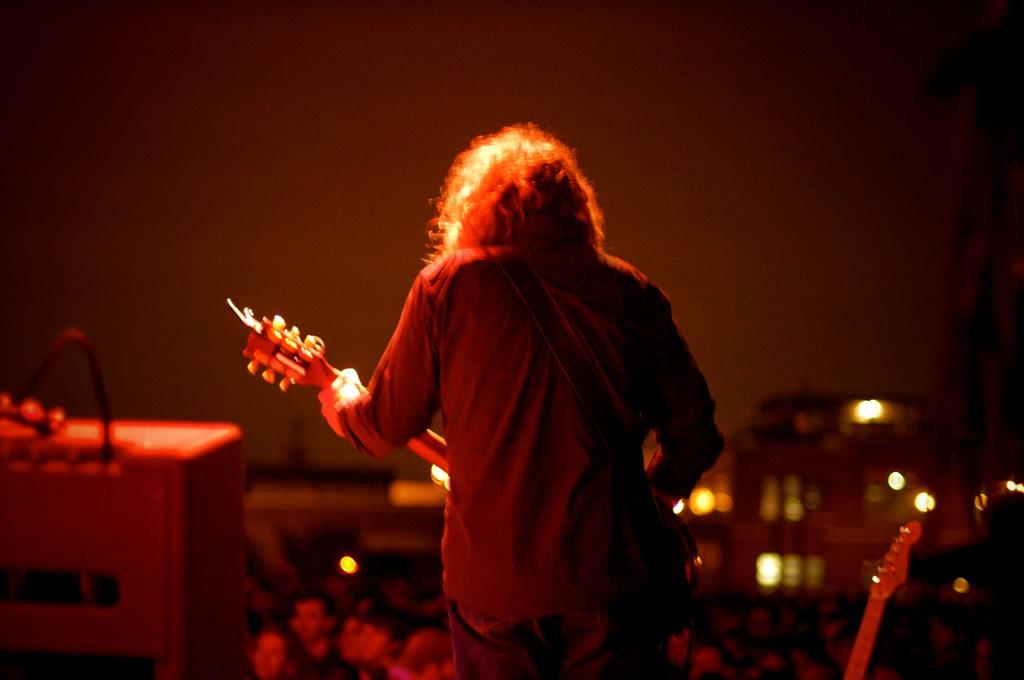What is the main subject of the image? There is a person in the image. What is the person doing in the image? The person is holding a musical instrument. What can be seen in the background of the image? The sky is visible in the image. How would you describe the lighting in the image? The scenery is dark. What type of animal is participating in the feast in the image? There is no animal or feast present in the image. What kind of skin is visible on the person in the image? The image does not provide enough detail to determine the type of skin visible on the person. 